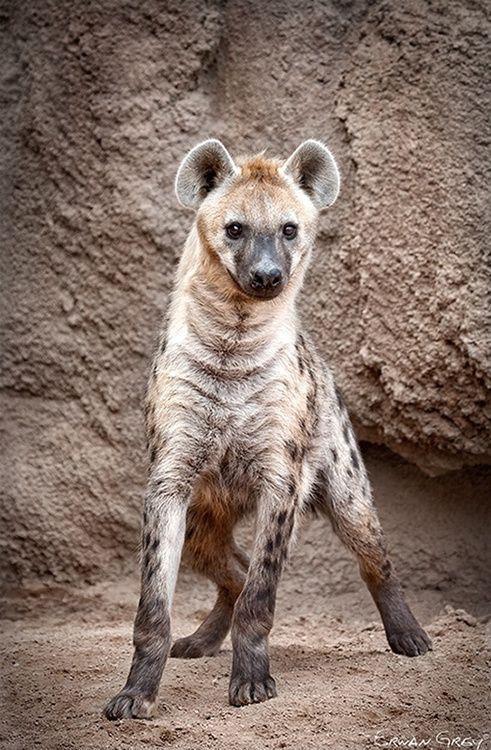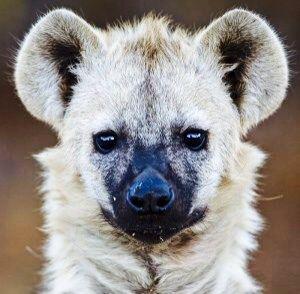The first image is the image on the left, the second image is the image on the right. Examine the images to the left and right. Is the description "At least two prairie dogs are looking straight ahead." accurate? Answer yes or no. Yes. The first image is the image on the left, the second image is the image on the right. Given the left and right images, does the statement "The right image has an animal looking to the left." hold true? Answer yes or no. No. 